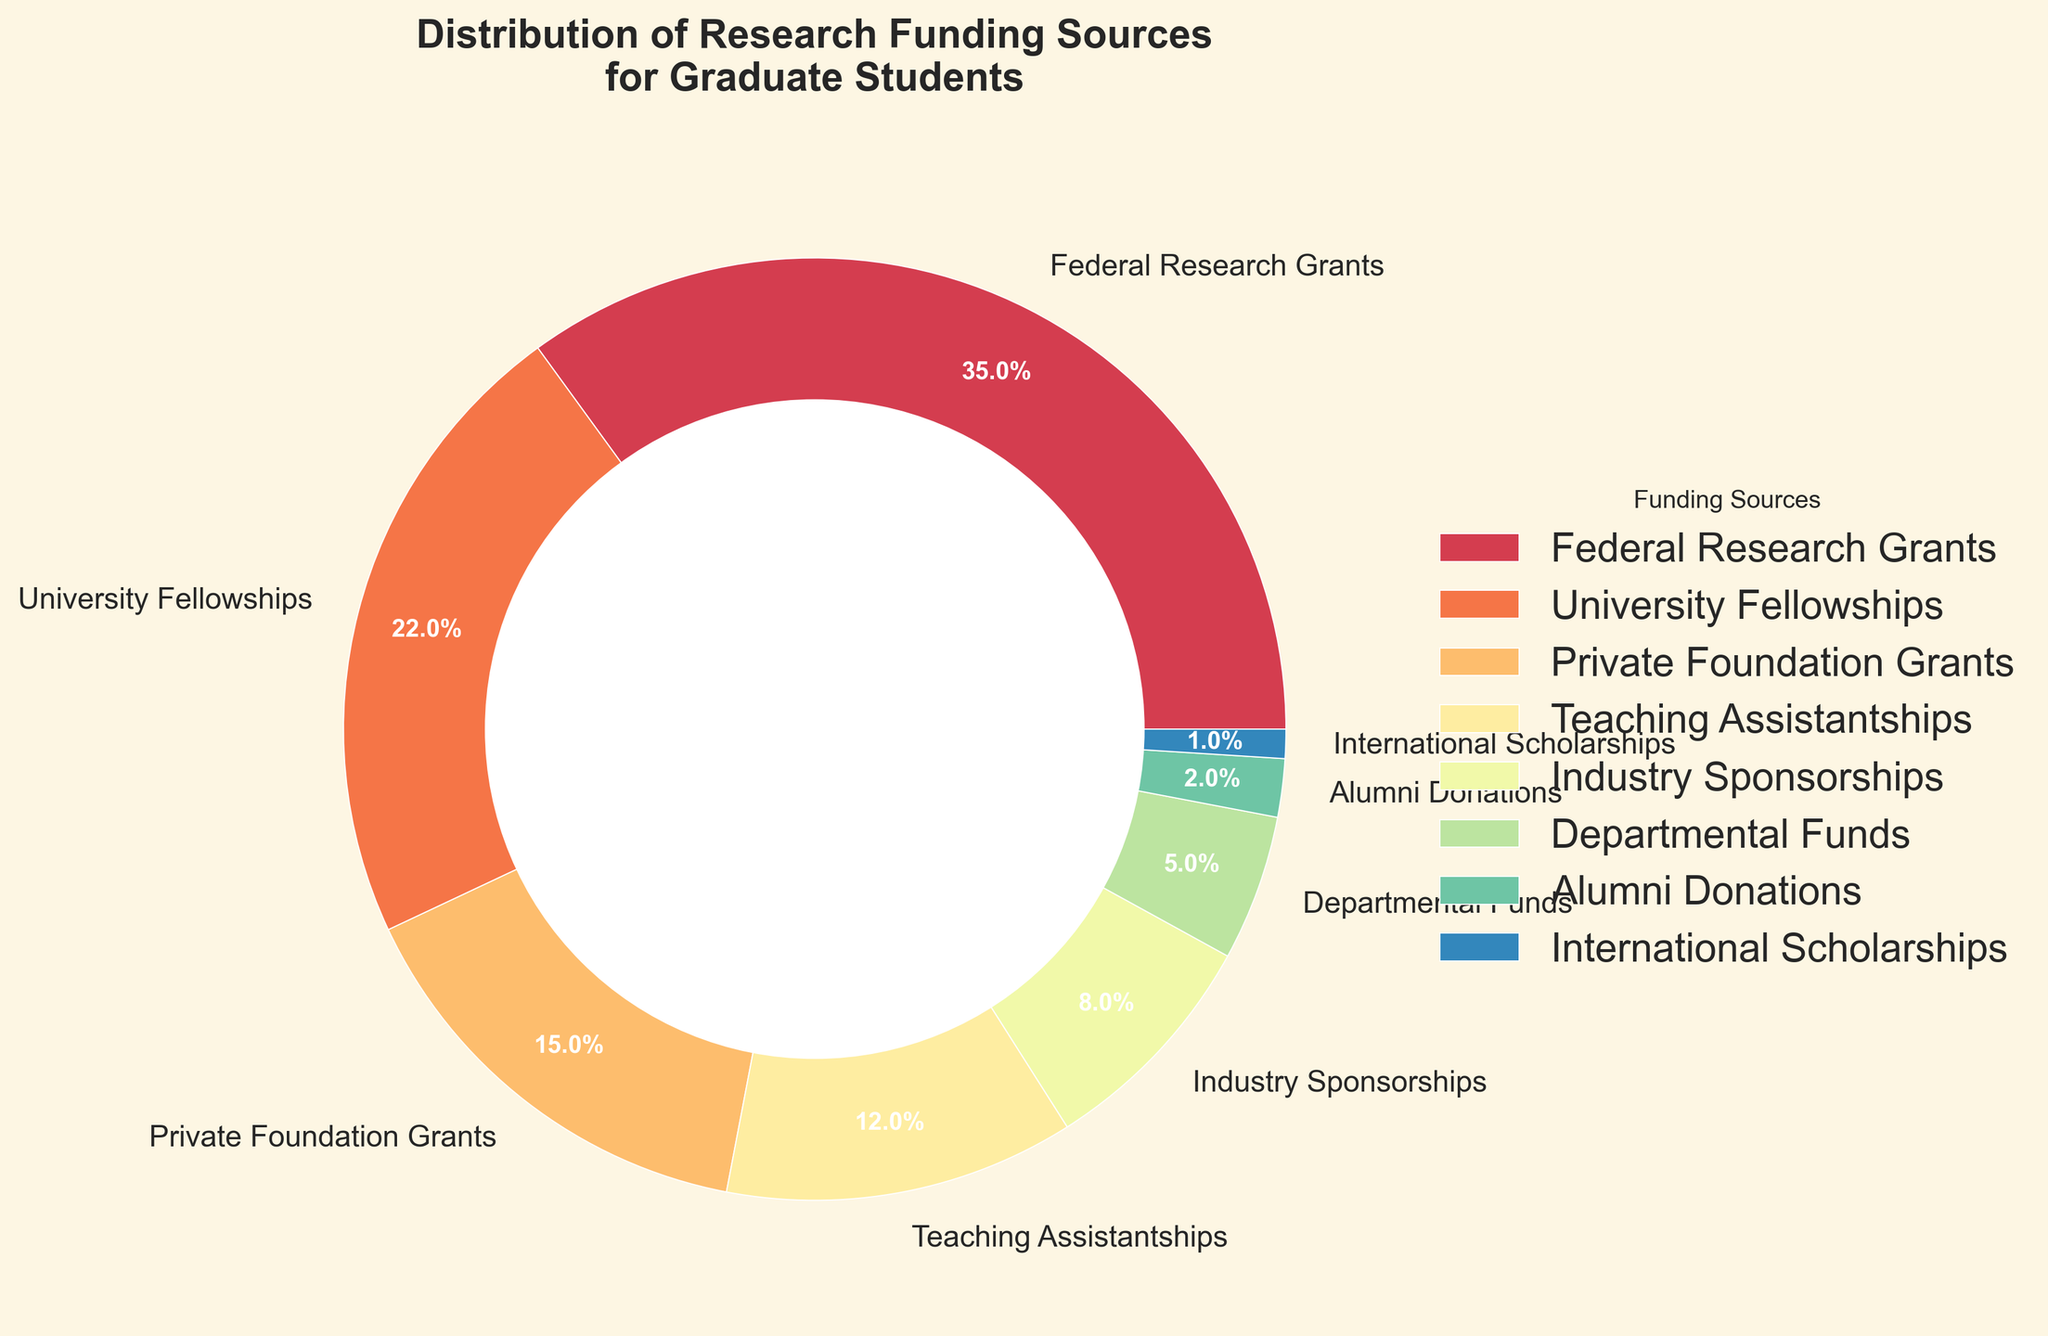What percentage of the research funding comes from Federal Research Grants and University Fellowships combined? Federal Research Grants contribute 35%, and University Fellowships contribute 22%. Adding these together gives 35% + 22% = 57%.
Answer: 57% Which funding source has the smallest percentage, and what is its value? The funding source with the smallest percentage is International Scholarships, with a value of 1%.
Answer: International Scholarships, 1% Which funding source contributes more, Private Foundation Grants or Teaching Assistantships, and by how much? Private Foundation Grants contribute 15%, while Teaching Assistantships contribute 12%. The difference is 15% - 12% = 3%.
Answer: Private Foundation Grants by 3% What are the top three sources of research funding for graduate students based on their percentage contributions? The top three sources of research funding are Federal Research Grants (35%), followed by University Fellowships (22%), and then Private Foundation Grants (15%).
Answer: Federal Research Grants, University Fellowships, Private Foundation Grants What is the combined percentage of the funding sources that contribute less than 10% each? The funding sources that contribute less than 10% are Industry Sponsorships (8%), Departmental Funds (5%), Alumni Donations (2%), and International Scholarships (1%). Adding these together gives 8% + 5% + 2% + 1% = 16%.
Answer: 16% How much more does the largest funding source contribute compared to the smallest funding source? The largest funding source is Federal Research Grants (35%) and the smallest is International Scholarships (1%). The difference is 35% - 1% = 34%.
Answer: 34% Among the funding sources, which ones contribute an equal percentage to the total research funding? No two funding sources have equal percentages in this figure; each source has a distinct contribution.
Answer: None Do Departmental Funds and Alumni Donations combined contribute more or less than Teaching Assistantships alone? Departmental Funds contribute 5%, and Alumni Donations contribute 2%. Combined, they add up to 5% + 2% = 7%, which is less than the 12% from Teaching Assistantships.
Answer: Less Describe the visual style and structure of the pie chart. The pie chart uses a "Solarize_Light2" style with a donut chart effect created by a white circle in the center. Each slice of the pie is color-coded with labels and percentages displayed on each slice, and a legend is provided on the side.
Answer: Donut chart, solarized style, color-coded slices, labeled with percentages and legend Which source has a visual representation closest in terms of size and color to University Fellowships? Teaching Assistantships, represented with a slightly smaller slice but a nearby color in the spectrum of the color palette used, has a visual representation closest to University Fellowships.
Answer: Teaching Assistantships 